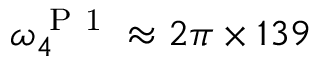Convert formula to latex. <formula><loc_0><loc_0><loc_500><loc_500>\omega _ { 4 } ^ { P 1 } \approx 2 \pi \times 1 3 9</formula> 